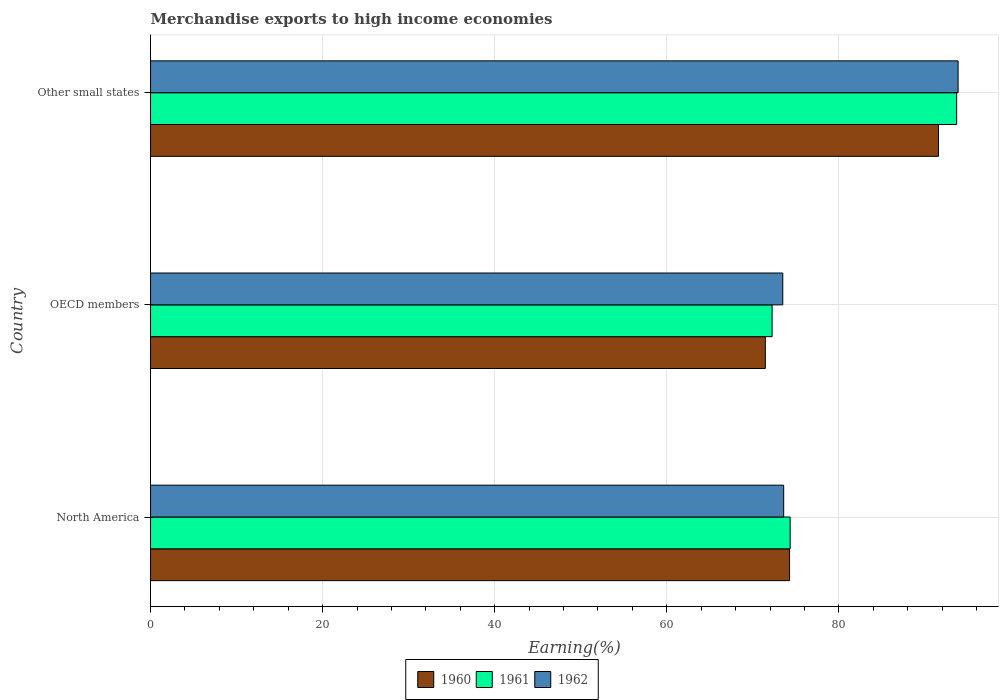How many different coloured bars are there?
Your response must be concise. 3. Are the number of bars per tick equal to the number of legend labels?
Make the answer very short. Yes. How many bars are there on the 3rd tick from the top?
Your answer should be compact. 3. How many bars are there on the 1st tick from the bottom?
Give a very brief answer. 3. In how many cases, is the number of bars for a given country not equal to the number of legend labels?
Offer a terse response. 0. What is the percentage of amount earned from merchandise exports in 1961 in Other small states?
Ensure brevity in your answer.  93.69. Across all countries, what is the maximum percentage of amount earned from merchandise exports in 1960?
Give a very brief answer. 91.57. Across all countries, what is the minimum percentage of amount earned from merchandise exports in 1961?
Your answer should be very brief. 72.24. In which country was the percentage of amount earned from merchandise exports in 1961 maximum?
Make the answer very short. Other small states. In which country was the percentage of amount earned from merchandise exports in 1960 minimum?
Your response must be concise. OECD members. What is the total percentage of amount earned from merchandise exports in 1962 in the graph?
Your answer should be very brief. 240.92. What is the difference between the percentage of amount earned from merchandise exports in 1961 in OECD members and that in Other small states?
Your answer should be very brief. -21.45. What is the difference between the percentage of amount earned from merchandise exports in 1960 in North America and the percentage of amount earned from merchandise exports in 1961 in Other small states?
Give a very brief answer. -19.42. What is the average percentage of amount earned from merchandise exports in 1960 per country?
Make the answer very short. 79.1. What is the difference between the percentage of amount earned from merchandise exports in 1961 and percentage of amount earned from merchandise exports in 1962 in OECD members?
Your answer should be compact. -1.24. In how many countries, is the percentage of amount earned from merchandise exports in 1960 greater than 84 %?
Ensure brevity in your answer.  1. What is the ratio of the percentage of amount earned from merchandise exports in 1960 in North America to that in Other small states?
Your answer should be very brief. 0.81. Is the percentage of amount earned from merchandise exports in 1961 in OECD members less than that in Other small states?
Provide a succinct answer. Yes. Is the difference between the percentage of amount earned from merchandise exports in 1961 in North America and Other small states greater than the difference between the percentage of amount earned from merchandise exports in 1962 in North America and Other small states?
Give a very brief answer. Yes. What is the difference between the highest and the second highest percentage of amount earned from merchandise exports in 1960?
Provide a succinct answer. 17.3. What is the difference between the highest and the lowest percentage of amount earned from merchandise exports in 1960?
Give a very brief answer. 20.12. What does the 2nd bar from the top in Other small states represents?
Provide a short and direct response. 1961. What does the 3rd bar from the bottom in Other small states represents?
Make the answer very short. 1962. Is it the case that in every country, the sum of the percentage of amount earned from merchandise exports in 1961 and percentage of amount earned from merchandise exports in 1962 is greater than the percentage of amount earned from merchandise exports in 1960?
Provide a short and direct response. Yes. Are all the bars in the graph horizontal?
Offer a terse response. Yes. What is the difference between two consecutive major ticks on the X-axis?
Give a very brief answer. 20. Are the values on the major ticks of X-axis written in scientific E-notation?
Keep it short and to the point. No. Does the graph contain any zero values?
Your answer should be compact. No. Does the graph contain grids?
Give a very brief answer. Yes. Where does the legend appear in the graph?
Your answer should be very brief. Bottom center. How are the legend labels stacked?
Provide a succinct answer. Horizontal. What is the title of the graph?
Your answer should be compact. Merchandise exports to high income economies. Does "1965" appear as one of the legend labels in the graph?
Offer a very short reply. No. What is the label or title of the X-axis?
Your answer should be very brief. Earning(%). What is the Earning(%) of 1960 in North America?
Your answer should be compact. 74.27. What is the Earning(%) in 1961 in North America?
Offer a terse response. 74.33. What is the Earning(%) of 1962 in North America?
Give a very brief answer. 73.58. What is the Earning(%) of 1960 in OECD members?
Your answer should be compact. 71.45. What is the Earning(%) in 1961 in OECD members?
Your answer should be very brief. 72.24. What is the Earning(%) of 1962 in OECD members?
Keep it short and to the point. 73.48. What is the Earning(%) in 1960 in Other small states?
Ensure brevity in your answer.  91.57. What is the Earning(%) of 1961 in Other small states?
Offer a terse response. 93.69. What is the Earning(%) in 1962 in Other small states?
Your answer should be compact. 93.86. Across all countries, what is the maximum Earning(%) in 1960?
Your response must be concise. 91.57. Across all countries, what is the maximum Earning(%) in 1961?
Ensure brevity in your answer.  93.69. Across all countries, what is the maximum Earning(%) in 1962?
Offer a terse response. 93.86. Across all countries, what is the minimum Earning(%) in 1960?
Give a very brief answer. 71.45. Across all countries, what is the minimum Earning(%) in 1961?
Provide a succinct answer. 72.24. Across all countries, what is the minimum Earning(%) of 1962?
Give a very brief answer. 73.48. What is the total Earning(%) of 1960 in the graph?
Give a very brief answer. 237.29. What is the total Earning(%) in 1961 in the graph?
Provide a short and direct response. 240.25. What is the total Earning(%) of 1962 in the graph?
Your answer should be very brief. 240.92. What is the difference between the Earning(%) in 1960 in North America and that in OECD members?
Your response must be concise. 2.82. What is the difference between the Earning(%) of 1961 in North America and that in OECD members?
Give a very brief answer. 2.09. What is the difference between the Earning(%) in 1962 in North America and that in OECD members?
Give a very brief answer. 0.11. What is the difference between the Earning(%) of 1960 in North America and that in Other small states?
Provide a succinct answer. -17.3. What is the difference between the Earning(%) of 1961 in North America and that in Other small states?
Your response must be concise. -19.35. What is the difference between the Earning(%) of 1962 in North America and that in Other small states?
Make the answer very short. -20.27. What is the difference between the Earning(%) of 1960 in OECD members and that in Other small states?
Your answer should be very brief. -20.12. What is the difference between the Earning(%) in 1961 in OECD members and that in Other small states?
Your response must be concise. -21.45. What is the difference between the Earning(%) of 1962 in OECD members and that in Other small states?
Your answer should be compact. -20.38. What is the difference between the Earning(%) of 1960 in North America and the Earning(%) of 1961 in OECD members?
Make the answer very short. 2.03. What is the difference between the Earning(%) of 1960 in North America and the Earning(%) of 1962 in OECD members?
Keep it short and to the point. 0.79. What is the difference between the Earning(%) of 1961 in North America and the Earning(%) of 1962 in OECD members?
Your answer should be compact. 0.85. What is the difference between the Earning(%) of 1960 in North America and the Earning(%) of 1961 in Other small states?
Keep it short and to the point. -19.42. What is the difference between the Earning(%) in 1960 in North America and the Earning(%) in 1962 in Other small states?
Make the answer very short. -19.59. What is the difference between the Earning(%) in 1961 in North America and the Earning(%) in 1962 in Other small states?
Provide a succinct answer. -19.52. What is the difference between the Earning(%) of 1960 in OECD members and the Earning(%) of 1961 in Other small states?
Give a very brief answer. -22.23. What is the difference between the Earning(%) of 1960 in OECD members and the Earning(%) of 1962 in Other small states?
Offer a very short reply. -22.4. What is the difference between the Earning(%) of 1961 in OECD members and the Earning(%) of 1962 in Other small states?
Your response must be concise. -21.62. What is the average Earning(%) in 1960 per country?
Your answer should be compact. 79.1. What is the average Earning(%) in 1961 per country?
Give a very brief answer. 80.08. What is the average Earning(%) of 1962 per country?
Give a very brief answer. 80.31. What is the difference between the Earning(%) in 1960 and Earning(%) in 1961 in North America?
Your answer should be compact. -0.07. What is the difference between the Earning(%) of 1960 and Earning(%) of 1962 in North America?
Provide a succinct answer. 0.68. What is the difference between the Earning(%) in 1961 and Earning(%) in 1962 in North America?
Provide a short and direct response. 0.75. What is the difference between the Earning(%) in 1960 and Earning(%) in 1961 in OECD members?
Offer a terse response. -0.79. What is the difference between the Earning(%) in 1960 and Earning(%) in 1962 in OECD members?
Provide a short and direct response. -2.03. What is the difference between the Earning(%) of 1961 and Earning(%) of 1962 in OECD members?
Your answer should be compact. -1.24. What is the difference between the Earning(%) in 1960 and Earning(%) in 1961 in Other small states?
Make the answer very short. -2.11. What is the difference between the Earning(%) of 1960 and Earning(%) of 1962 in Other small states?
Your answer should be compact. -2.28. What is the difference between the Earning(%) of 1961 and Earning(%) of 1962 in Other small states?
Offer a terse response. -0.17. What is the ratio of the Earning(%) in 1960 in North America to that in OECD members?
Provide a succinct answer. 1.04. What is the ratio of the Earning(%) of 1961 in North America to that in OECD members?
Your response must be concise. 1.03. What is the ratio of the Earning(%) of 1962 in North America to that in OECD members?
Provide a short and direct response. 1. What is the ratio of the Earning(%) of 1960 in North America to that in Other small states?
Your answer should be very brief. 0.81. What is the ratio of the Earning(%) of 1961 in North America to that in Other small states?
Provide a succinct answer. 0.79. What is the ratio of the Earning(%) in 1962 in North America to that in Other small states?
Make the answer very short. 0.78. What is the ratio of the Earning(%) in 1960 in OECD members to that in Other small states?
Keep it short and to the point. 0.78. What is the ratio of the Earning(%) in 1961 in OECD members to that in Other small states?
Provide a succinct answer. 0.77. What is the ratio of the Earning(%) in 1962 in OECD members to that in Other small states?
Offer a very short reply. 0.78. What is the difference between the highest and the second highest Earning(%) of 1960?
Provide a short and direct response. 17.3. What is the difference between the highest and the second highest Earning(%) in 1961?
Your answer should be compact. 19.35. What is the difference between the highest and the second highest Earning(%) in 1962?
Your response must be concise. 20.27. What is the difference between the highest and the lowest Earning(%) of 1960?
Your answer should be compact. 20.12. What is the difference between the highest and the lowest Earning(%) of 1961?
Offer a terse response. 21.45. What is the difference between the highest and the lowest Earning(%) in 1962?
Offer a very short reply. 20.38. 